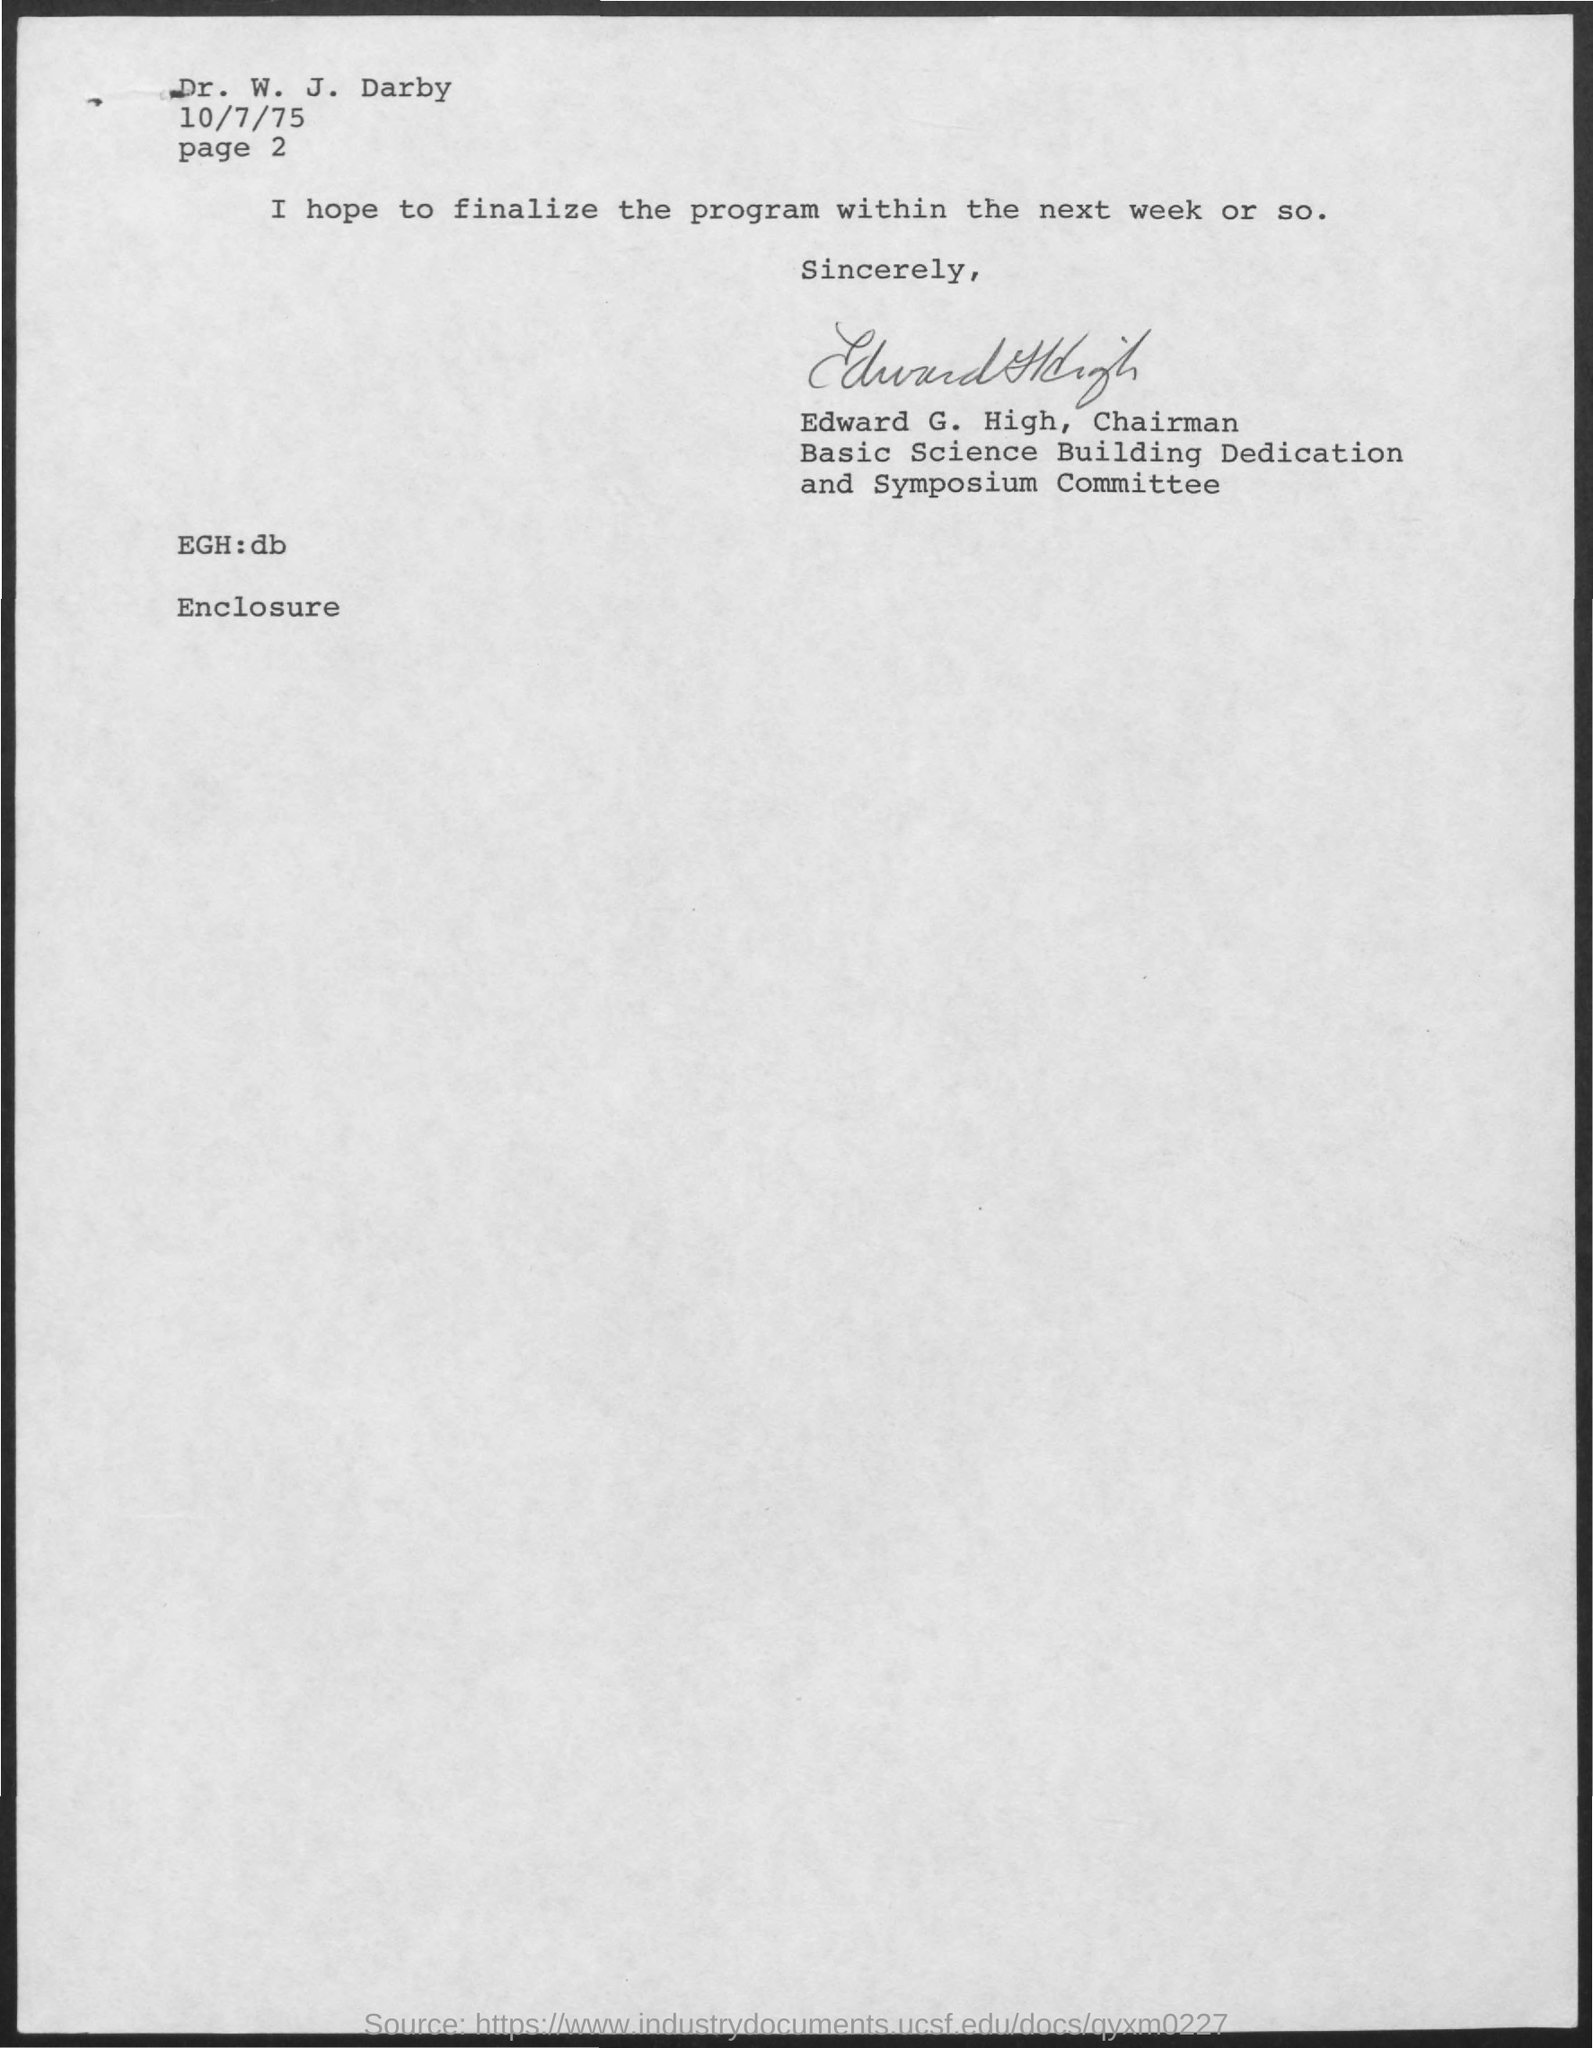Who has signed this letter?
Your answer should be compact. Edward g. high. Who is the addressee of this letter?
Your response must be concise. Dr. W. J. Darby. What is the issued date of this letter?
Your response must be concise. 10/7/75. 